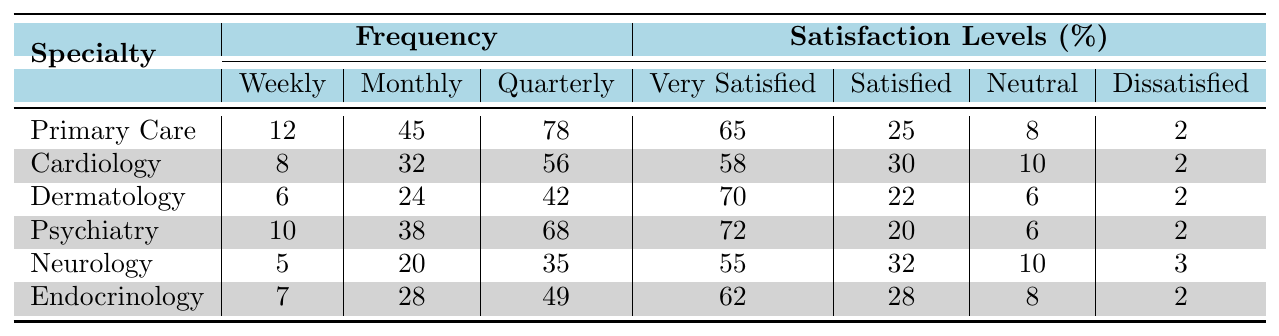How many weekly telehealth consultations are there for Psychiatry? The table indicates that there are 10 weekly telehealth consultations for Psychiatry listed under the Frequency section.
Answer: 10 What is the percentage of patients who are very satisfied with Dermatology telehealth consultations? From the Satisfaction Levels section for Dermatology, it shows that 70% of patients are very satisfied.
Answer: 70% Which specialty has the highest number of quarterly telehealth consultations? Looking at the Quarterly column, Primary Care has the highest number at 78 consultations compared to others.
Answer: Primary Care How many patients in total are either very satisfied or satisfied with Cardiology telehealth consultations? For Cardiology, the very satisfied percentage is 58% and satisfied is 30%. Adding these gives 58 + 30 = 88%.
Answer: 88% Is there a specialty that has more weekly consultations than Endocrinology? Comparing the Weekly consultations, Primary Care (12), Cardiology (8), and Psychiatry (10) all have more than Endocrinology (7). Thus, yes, there are specialties with more weekly consultations.
Answer: Yes What is the average satisfaction percentage for all specialties that are very satisfied? Summing the very satisfied percentages: 65 + 58 + 70 + 72 + 55 + 62 = 392. Dividing that by the number of specialties (6) gives an average of 392 / 6 = 65.33%.
Answer: 65.33% How many more people are dissatisfied with Neurology than Primary Care? The table indicates that Neurology has 3 dissatisfied patients while Primary Care has 2. The difference is 3 - 2 = 1.
Answer: 1 Which specialty has the least number of monthly consultations? Reviewing the Monthly column, Neurology has the least with 20 consultations compared to the other specialties.
Answer: Neurology What percentage of patients is neutral in their satisfaction with Psychiatry consultations? According to the Satisfaction Levels for Psychiatry, 6% of patients are neutral.
Answer: 6% Is the average monthly telehealth consultation frequency across all specialties greater than 30? Monthly frequencies are 45, 32, 24, 38, 20, 28. The total is 45 + 32 + 24 + 38 + 20 + 28 = 187. Dividing by 6 results in an average of 31.17, which is greater than 30.
Answer: Yes Which specialty has the lowest total of telehealth consultations across all frequency levels? Calculating the total for each specialty: Primary Care (135), Cardiology (96), Dermatology (72), Psychiatry (116), Neurology (60), Endocrinology (84). Neurology has the lowest total.
Answer: Neurology 